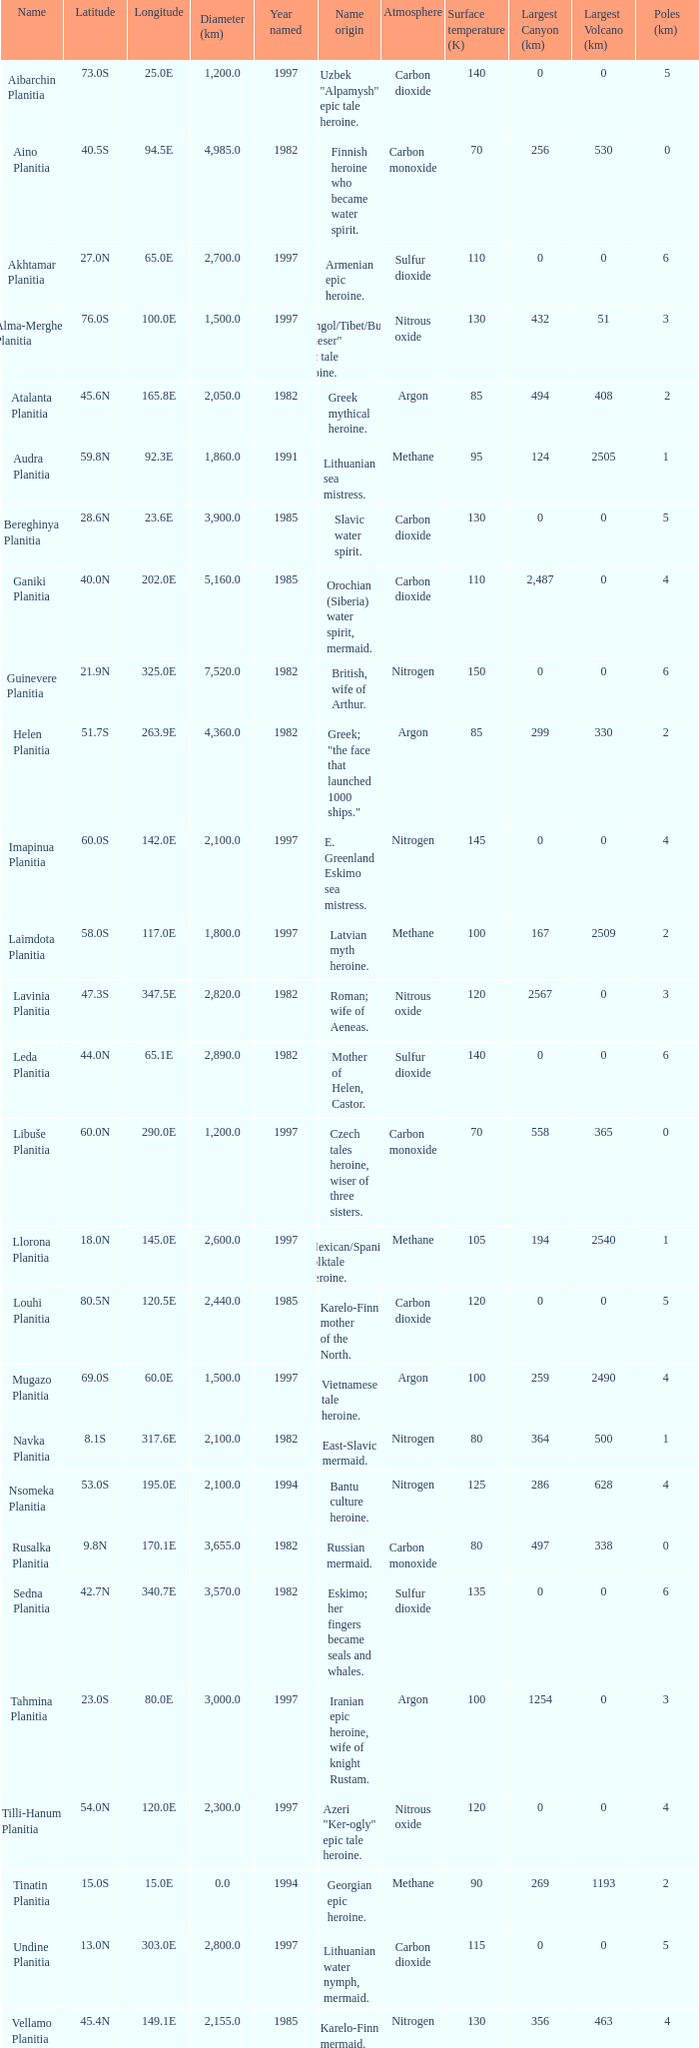Give me the full table as a dictionary. {'header': ['Name', 'Latitude', 'Longitude', 'Diameter (km)', 'Year named', 'Name origin', 'Atmosphere', 'Surface temperature (K)', 'Largest Canyon (km)', 'Largest Volcano (km)', 'Poles (km) '], 'rows': [['Aibarchin Planitia', '73.0S', '25.0E', '1,200.0', '1997', 'Uzbek "Alpamysh" epic tale heroine.', 'Carbon dioxide', '140', '0', '0', '5'], ['Aino Planitia', '40.5S', '94.5E', '4,985.0', '1982', 'Finnish heroine who became water spirit.', 'Carbon monoxide', '70', '256', '530', '0'], ['Akhtamar Planitia', '27.0N', '65.0E', '2,700.0', '1997', 'Armenian epic heroine.', 'Sulfur dioxide', '110', '0', '0', '6 '], ['Alma-Merghen Planitia', '76.0S', '100.0E', '1,500.0', '1997', 'Mongol/Tibet/Buryat "Gheser" epic tale heroine.', 'Nitrous oxide', '130', '432', '51', '3 '], ['Atalanta Planitia', '45.6N', '165.8E', '2,050.0', '1982', 'Greek mythical heroine.', 'Argon', '85', '494', '408', '2'], ['Audra Planitia', '59.8N', '92.3E', '1,860.0', '1991', 'Lithuanian sea mistress.', 'Methane', '95', '124', '2505', '1 '], ['Bereghinya Planitia', '28.6N', '23.6E', '3,900.0', '1985', 'Slavic water spirit.', 'Carbon dioxide', '130', '0', '0', '5 '], ['Ganiki Planitia', '40.0N', '202.0E', '5,160.0', '1985', 'Orochian (Siberia) water spirit, mermaid.', 'Carbon dioxide', '110', '2,487', '0', '4 '], ['Guinevere Planitia', '21.9N', '325.0E', '7,520.0', '1982', 'British, wife of Arthur.', 'Nitrogen', '150', '0', '0', '6 '], ['Helen Planitia', '51.7S', '263.9E', '4,360.0', '1982', 'Greek; "the face that launched 1000 ships."', 'Argon', '85', '299', '330', '2 '], ['Imapinua Planitia', '60.0S', '142.0E', '2,100.0', '1997', 'E. Greenland Eskimo sea mistress.', 'Nitrogen', '145', '0', '0', '4 '], ['Laimdota Planitia', '58.0S', '117.0E', '1,800.0', '1997', 'Latvian myth heroine.', 'Methane', '100', '167', '2509', '2 '], ['Lavinia Planitia', '47.3S', '347.5E', '2,820.0', '1982', 'Roman; wife of Aeneas.', 'Nitrous oxide', '120', '2567', '0', '3 '], ['Leda Planitia', '44.0N', '65.1E', '2,890.0', '1982', 'Mother of Helen, Castor.', 'Sulfur dioxide', '140', '0', '0', '6 '], ['Libuše Planitia', '60.0N', '290.0E', '1,200.0', '1997', 'Czech tales heroine, wiser of three sisters.', 'Carbon monoxide', '70', '558', '365', '0 '], ['Llorona Planitia', '18.0N', '145.0E', '2,600.0', '1997', 'Mexican/Spanish folktale heroine.', 'Methane', '105', '194', '2540', '1 '], ['Louhi Planitia', '80.5N', '120.5E', '2,440.0', '1985', 'Karelo-Finn mother of the North.', 'Carbon dioxide', '120', '0', '0', '5 '], ['Mugazo Planitia', '69.0S', '60.0E', '1,500.0', '1997', 'Vietnamese tale heroine.', 'Argon', '100', '259', '2490', '4 '], ['Navka Planitia', '8.1S', '317.6E', '2,100.0', '1982', 'East-Slavic mermaid.', 'Nitrogen', '80', '364', '500', '1 '], ['Nsomeka Planitia', '53.0S', '195.0E', '2,100.0', '1994', 'Bantu culture heroine.', 'Nitrogen', '125', '286', '628', '4 '], ['Rusalka Planitia', '9.8N', '170.1E', '3,655.0', '1982', 'Russian mermaid.', 'Carbon monoxide', '80', '497', '338', '0 '], ['Sedna Planitia', '42.7N', '340.7E', '3,570.0', '1982', 'Eskimo; her fingers became seals and whales.', 'Sulfur dioxide', '135', '0', '0', '6 '], ['Tahmina Planitia', '23.0S', '80.0E', '3,000.0', '1997', 'Iranian epic heroine, wife of knight Rustam.', 'Argon', '100', '1254', '0', '3 '], ['Tilli-Hanum Planitia', '54.0N', '120.0E', '2,300.0', '1997', 'Azeri "Ker-ogly" epic tale heroine.', 'Nitrous oxide', '120', '0', '0', '4 '], ['Tinatin Planitia', '15.0S', '15.0E', '0.0', '1994', 'Georgian epic heroine.', 'Methane', '90', '269', '1193', '2 '], ['Undine Planitia', '13.0N', '303.0E', '2,800.0', '1997', 'Lithuanian water nymph, mermaid.', 'Carbon dioxide', '115', '0', '0', '5 '], ['Vellamo Planitia', '45.4N', '149.1E', '2,155.0', '1985', 'Karelo-Finn mermaid.', 'Nitrogen', '130', '356', '463', '4']]} What is the diameter (km) of the feature of latitude 23.0s 3000.0. 